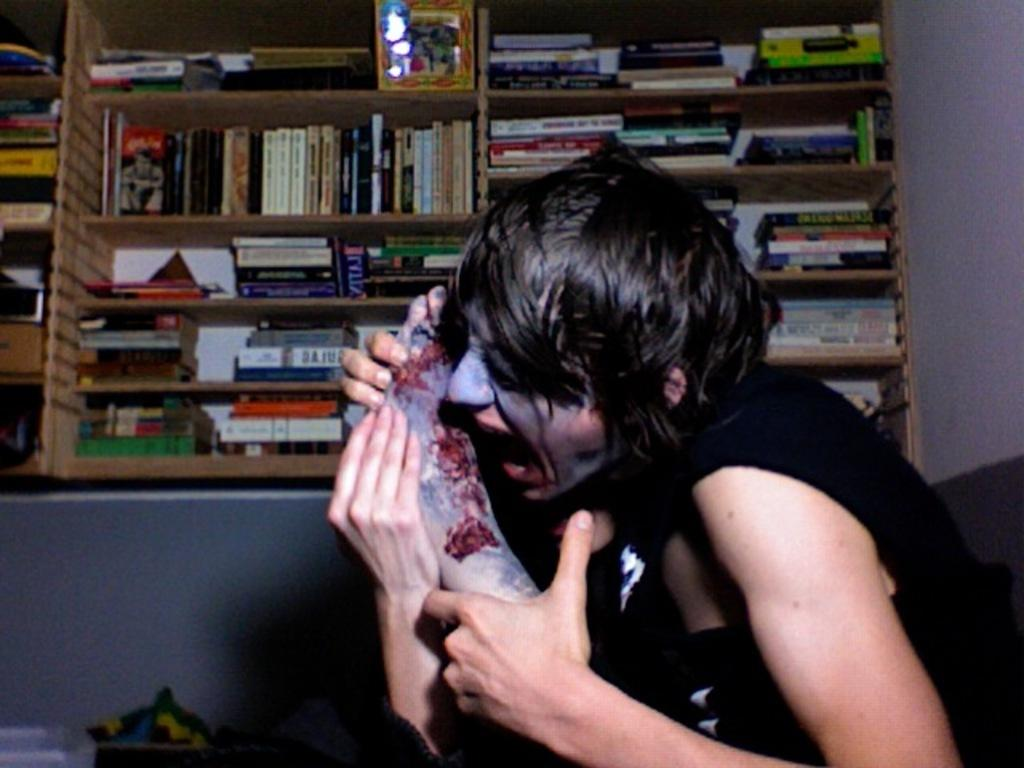Who is the main subject in the image? There is a woman in the center of the image. What can be seen in the background of the image? There are many books arranged in shelves in the background, and a wall is also visible. What type of test is being conducted in the image? There is no test being conducted in the image; it features a woman and bookshelves in the background. How many apples are on the table in the image? There are no apples present in the image. 